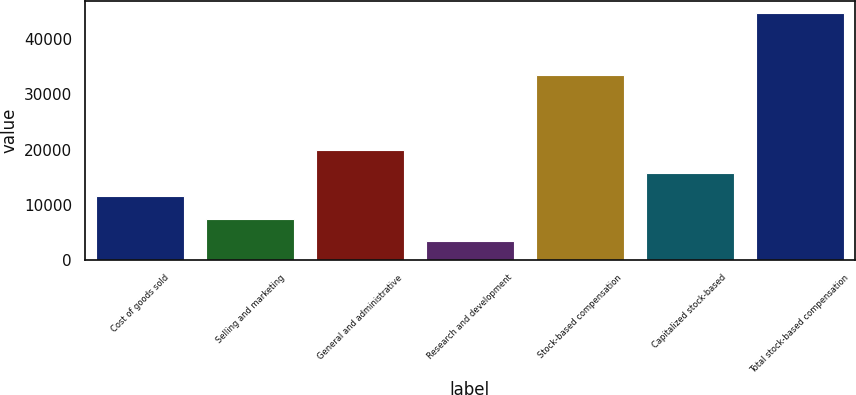Convert chart to OTSL. <chart><loc_0><loc_0><loc_500><loc_500><bar_chart><fcel>Cost of goods sold<fcel>Selling and marketing<fcel>General and administrative<fcel>Research and development<fcel>Stock-based compensation<fcel>Capitalized stock-based<fcel>Total stock-based compensation<nl><fcel>11618.8<fcel>7481.9<fcel>19963<fcel>3345<fcel>33494<fcel>15755.7<fcel>44714<nl></chart> 